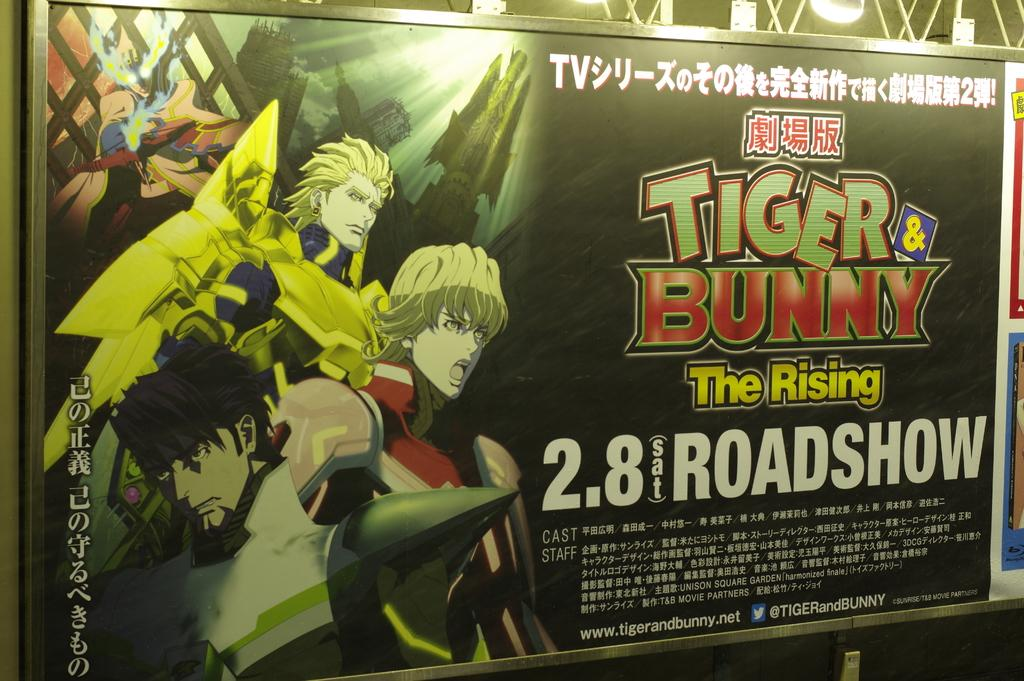What is the main object in the center of the image? There is a board with text and images in the center of the image. What can be seen in the background of the image? There is a grill in the background of the image. What is the color of the grill? The grill is white in color. How many hands are holding the butter in the image? There is no butter present in the image, so it is not possible to determine how many hands might be holding it. 